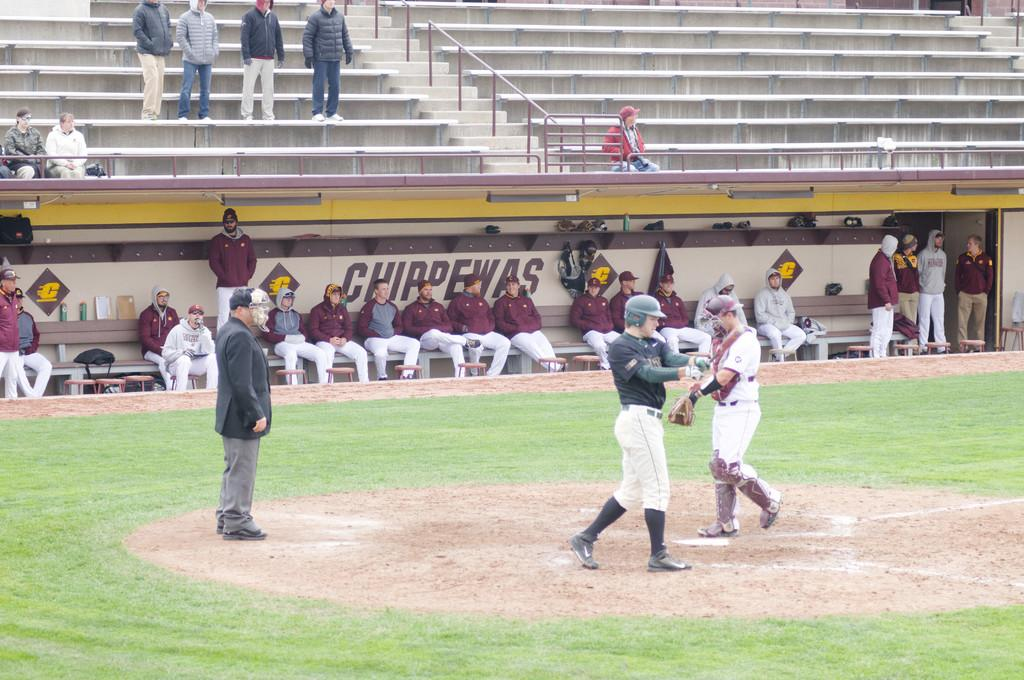Provide a one-sentence caption for the provided image. Sports team members sit on a bench in front of a wall labeled Chippewas. 